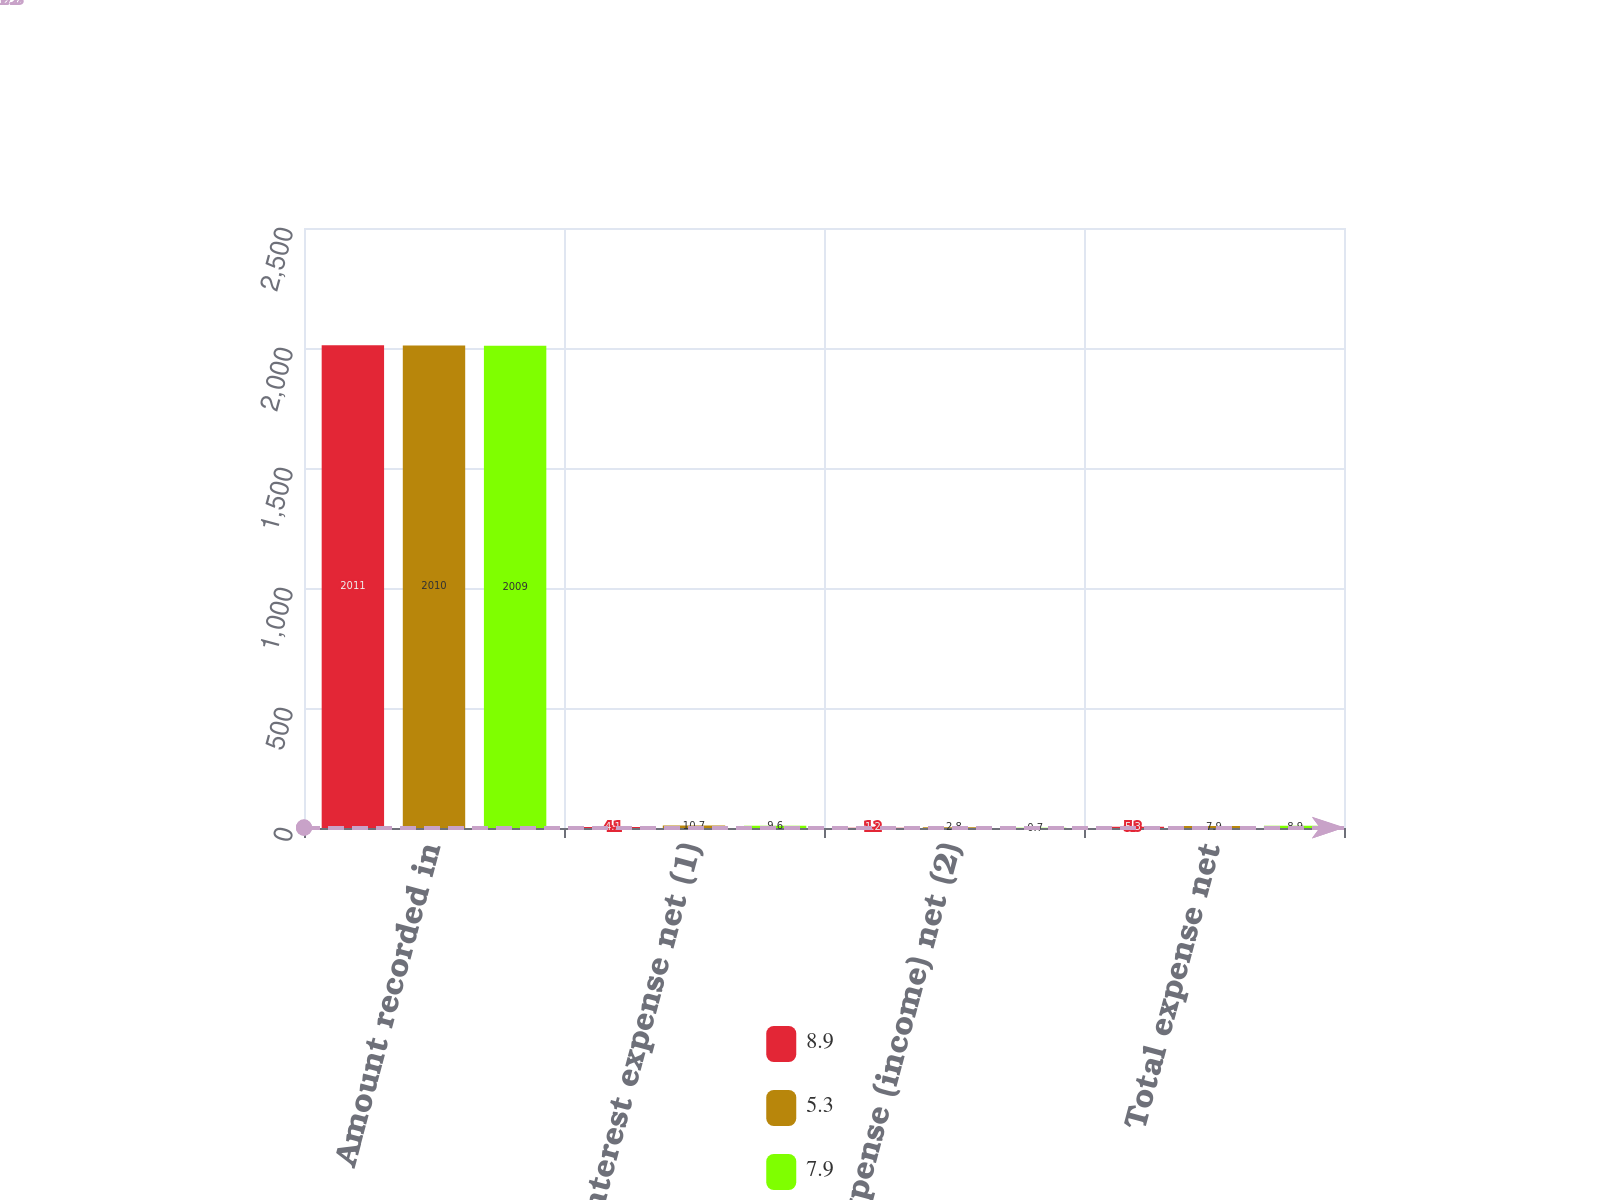Convert chart. <chart><loc_0><loc_0><loc_500><loc_500><stacked_bar_chart><ecel><fcel>Amount recorded in<fcel>Interest expense net (1)<fcel>Other expense (income) net (2)<fcel>Total expense net<nl><fcel>8.9<fcel>2011<fcel>4.1<fcel>1.2<fcel>5.3<nl><fcel>5.3<fcel>2010<fcel>10.7<fcel>2.8<fcel>7.9<nl><fcel>7.9<fcel>2009<fcel>9.6<fcel>0.7<fcel>8.9<nl></chart> 